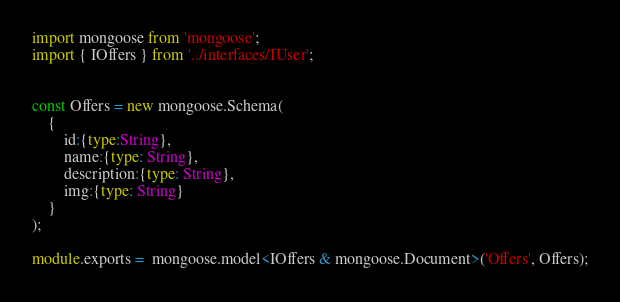Convert code to text. <code><loc_0><loc_0><loc_500><loc_500><_TypeScript_>import mongoose from 'mongoose';
import { IOffers } from '../interfaces/IUser';


const Offers = new mongoose.Schema(
    {
        id:{type:String},
        name:{type: String},
        description:{type: String},
        img:{type: String}       
    }
);

module.exports =  mongoose.model<IOffers & mongoose.Document>('Offers', Offers);</code> 